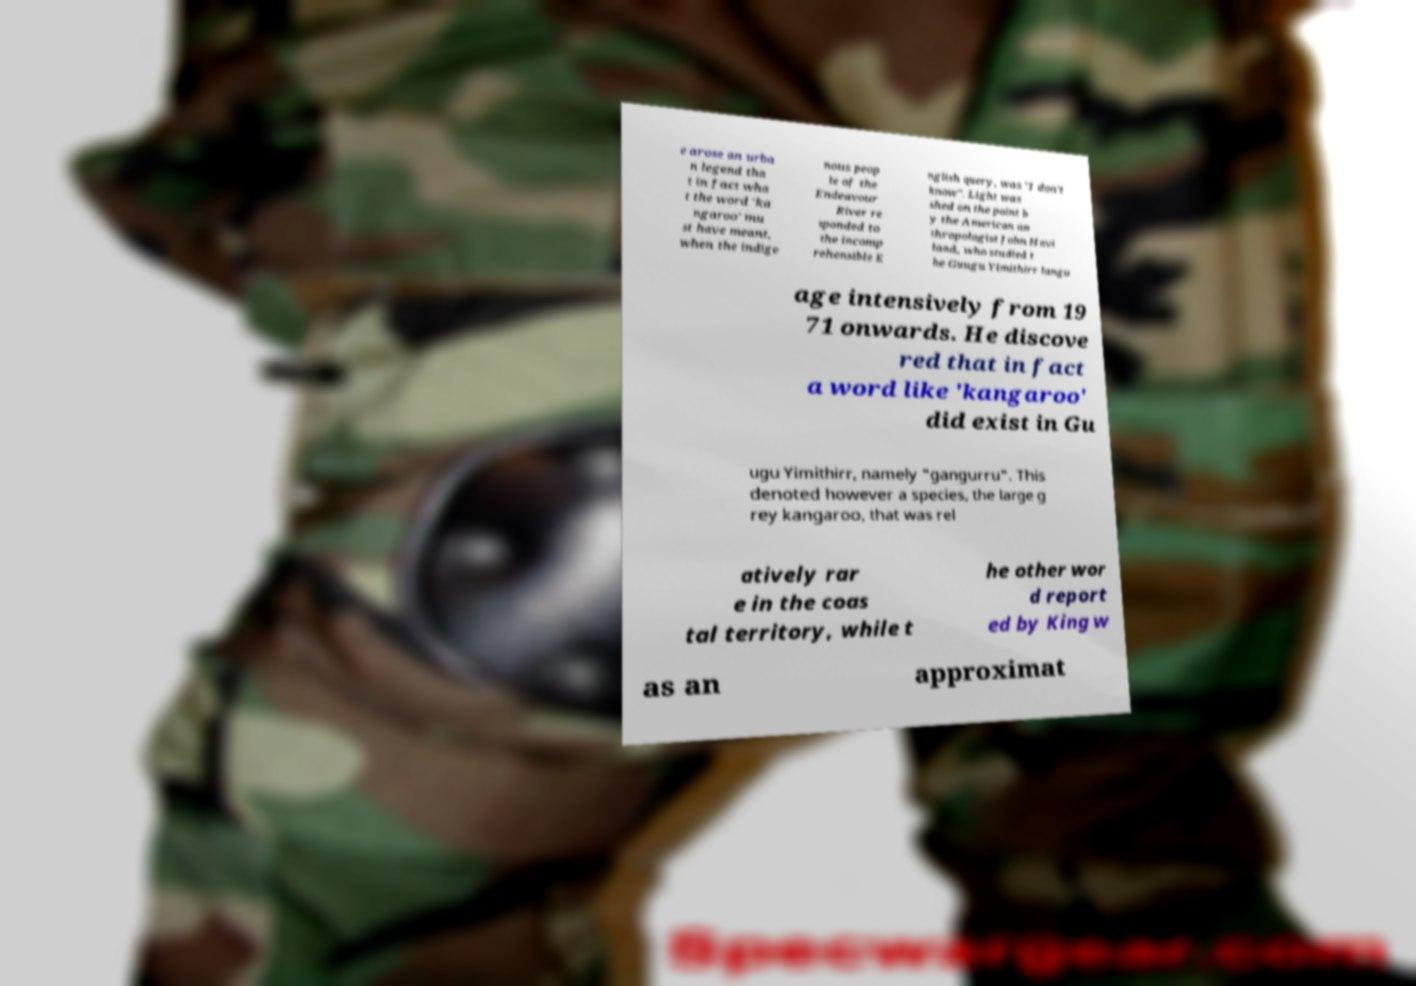For documentation purposes, I need the text within this image transcribed. Could you provide that? e arose an urba n legend tha t in fact wha t the word 'ka ngaroo' mu st have meant, when the indige nous peop le of the Endeavour River re sponded to the incomp rehensible E nglish query, was "I don't know". Light was shed on the point b y the American an thropologist John Havi land, who studied t he Guugu Yimithirr langu age intensively from 19 71 onwards. He discove red that in fact a word like 'kangaroo' did exist in Gu ugu Yimithirr, namely "gangurru". This denoted however a species, the large g rey kangaroo, that was rel atively rar e in the coas tal territory, while t he other wor d report ed by King w as an approximat 